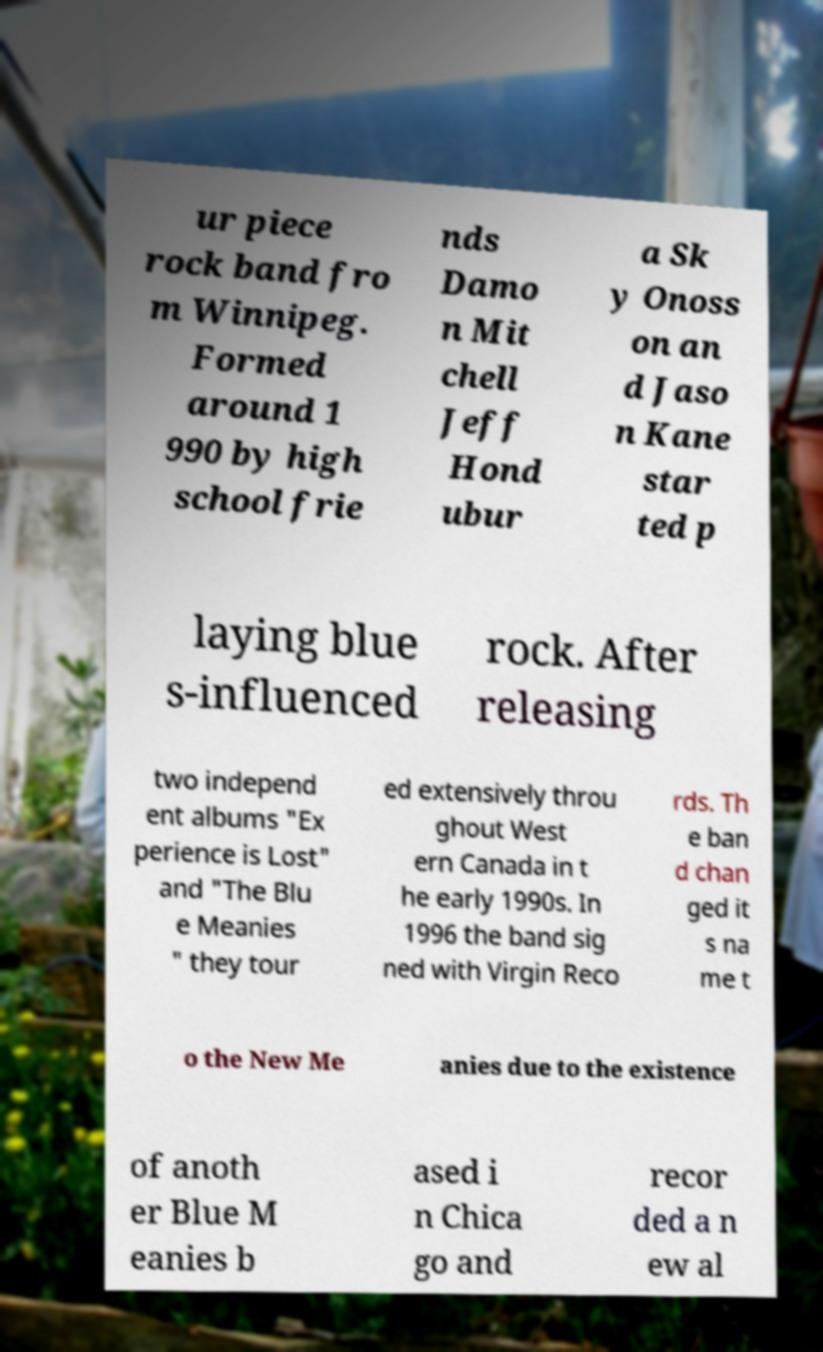Please read and relay the text visible in this image. What does it say? ur piece rock band fro m Winnipeg. Formed around 1 990 by high school frie nds Damo n Mit chell Jeff Hond ubur a Sk y Onoss on an d Jaso n Kane star ted p laying blue s-influenced rock. After releasing two independ ent albums "Ex perience is Lost" and "The Blu e Meanies " they tour ed extensively throu ghout West ern Canada in t he early 1990s. In 1996 the band sig ned with Virgin Reco rds. Th e ban d chan ged it s na me t o the New Me anies due to the existence of anoth er Blue M eanies b ased i n Chica go and recor ded a n ew al 